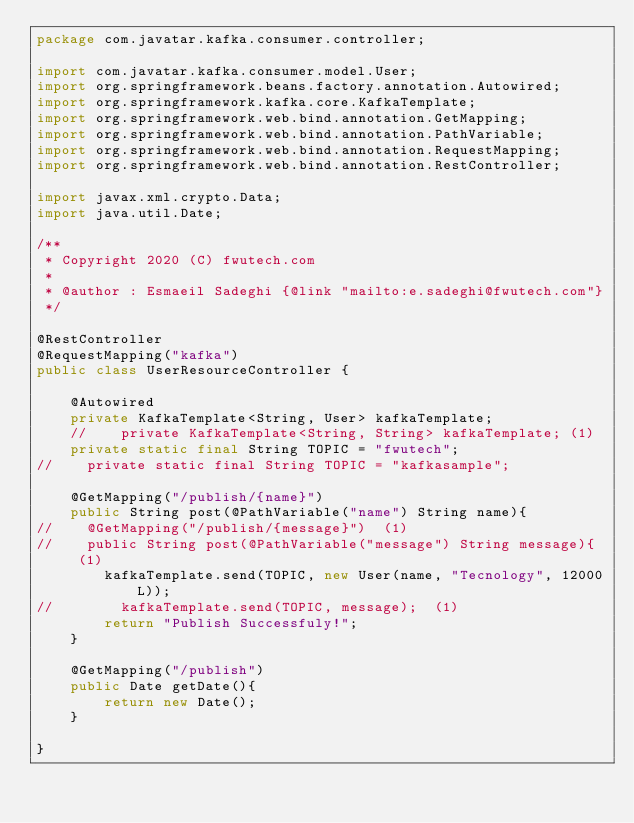<code> <loc_0><loc_0><loc_500><loc_500><_Java_>package com.javatar.kafka.consumer.controller;

import com.javatar.kafka.consumer.model.User;
import org.springframework.beans.factory.annotation.Autowired;
import org.springframework.kafka.core.KafkaTemplate;
import org.springframework.web.bind.annotation.GetMapping;
import org.springframework.web.bind.annotation.PathVariable;
import org.springframework.web.bind.annotation.RequestMapping;
import org.springframework.web.bind.annotation.RestController;

import javax.xml.crypto.Data;
import java.util.Date;

/**
 * Copyright 2020 (C) fwutech.com
 *
 * @author : Esmaeil Sadeghi {@link "mailto:e.sadeghi@fwutech.com"}
 */

@RestController
@RequestMapping("kafka")
public class UserResourceController {

    @Autowired
    private KafkaTemplate<String, User> kafkaTemplate;
    //    private KafkaTemplate<String, String> kafkaTemplate; (1)
    private static final String TOPIC = "fwutech";
//    private static final String TOPIC = "kafkasample";

    @GetMapping("/publish/{name}")
    public String post(@PathVariable("name") String name){
//    @GetMapping("/publish/{message}")  (1)
//    public String post(@PathVariable("message") String message){  (1)
        kafkaTemplate.send(TOPIC, new User(name, "Tecnology", 12000L));
//        kafkaTemplate.send(TOPIC, message);  (1)
        return "Publish Successfuly!";
    }

    @GetMapping("/publish")
    public Date getDate(){
        return new Date();
    }

}</code> 